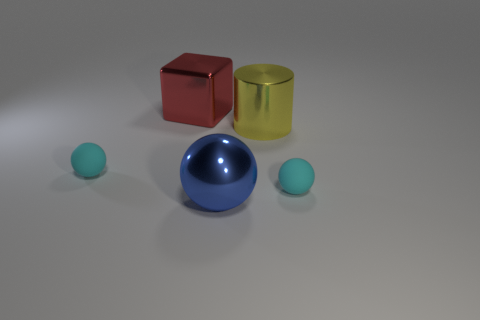Subtract all cyan spheres. How many were subtracted if there are1cyan spheres left? 1 Subtract all large blue metal spheres. How many spheres are left? 2 Subtract all yellow cylinders. How many cyan balls are left? 2 Add 1 large blue metallic spheres. How many objects exist? 6 Subtract all yellow balls. Subtract all yellow cubes. How many balls are left? 3 Subtract all blocks. How many objects are left? 4 Subtract all metal cylinders. Subtract all red things. How many objects are left? 3 Add 1 big red metal objects. How many big red metal objects are left? 2 Add 4 big blue matte spheres. How many big blue matte spheres exist? 4 Subtract 0 yellow cubes. How many objects are left? 5 